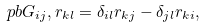Convert formula to latex. <formula><loc_0><loc_0><loc_500><loc_500>\ p b { G _ { i j } , r _ { k l } } = \delta _ { i l } r _ { k j } - \delta _ { j l } r _ { k i } ,</formula> 